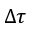Convert formula to latex. <formula><loc_0><loc_0><loc_500><loc_500>\Delta \tau</formula> 